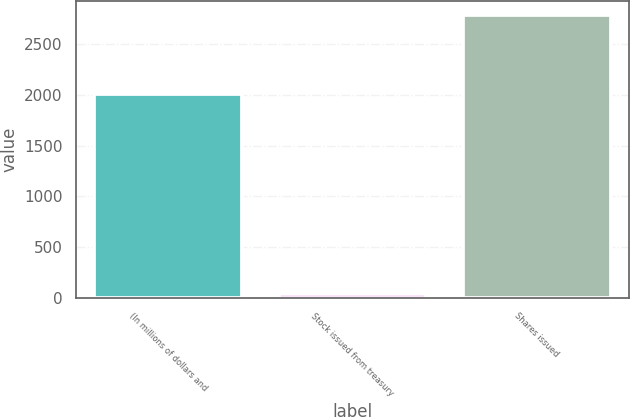<chart> <loc_0><loc_0><loc_500><loc_500><bar_chart><fcel>(In millions of dollars and<fcel>Stock issued from treasury<fcel>Shares issued<nl><fcel>2006<fcel>42<fcel>2783<nl></chart> 